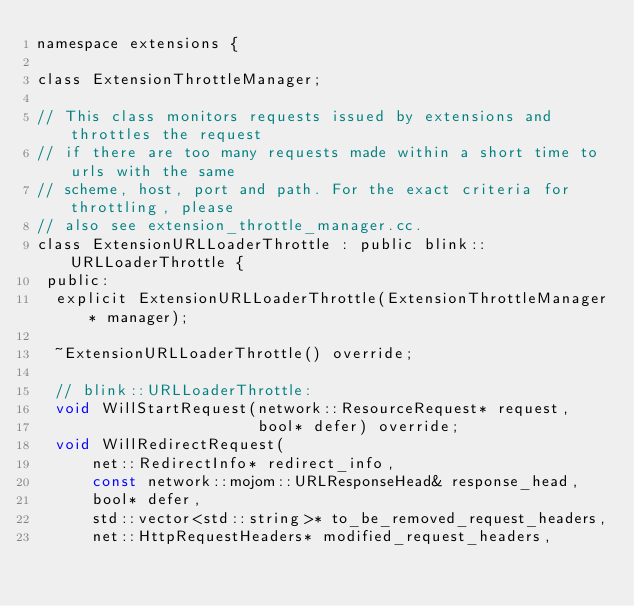<code> <loc_0><loc_0><loc_500><loc_500><_C_>namespace extensions {

class ExtensionThrottleManager;

// This class monitors requests issued by extensions and throttles the request
// if there are too many requests made within a short time to urls with the same
// scheme, host, port and path. For the exact criteria for throttling, please
// also see extension_throttle_manager.cc.
class ExtensionURLLoaderThrottle : public blink::URLLoaderThrottle {
 public:
  explicit ExtensionURLLoaderThrottle(ExtensionThrottleManager* manager);

  ~ExtensionURLLoaderThrottle() override;

  // blink::URLLoaderThrottle:
  void WillStartRequest(network::ResourceRequest* request,
                        bool* defer) override;
  void WillRedirectRequest(
      net::RedirectInfo* redirect_info,
      const network::mojom::URLResponseHead& response_head,
      bool* defer,
      std::vector<std::string>* to_be_removed_request_headers,
      net::HttpRequestHeaders* modified_request_headers,</code> 